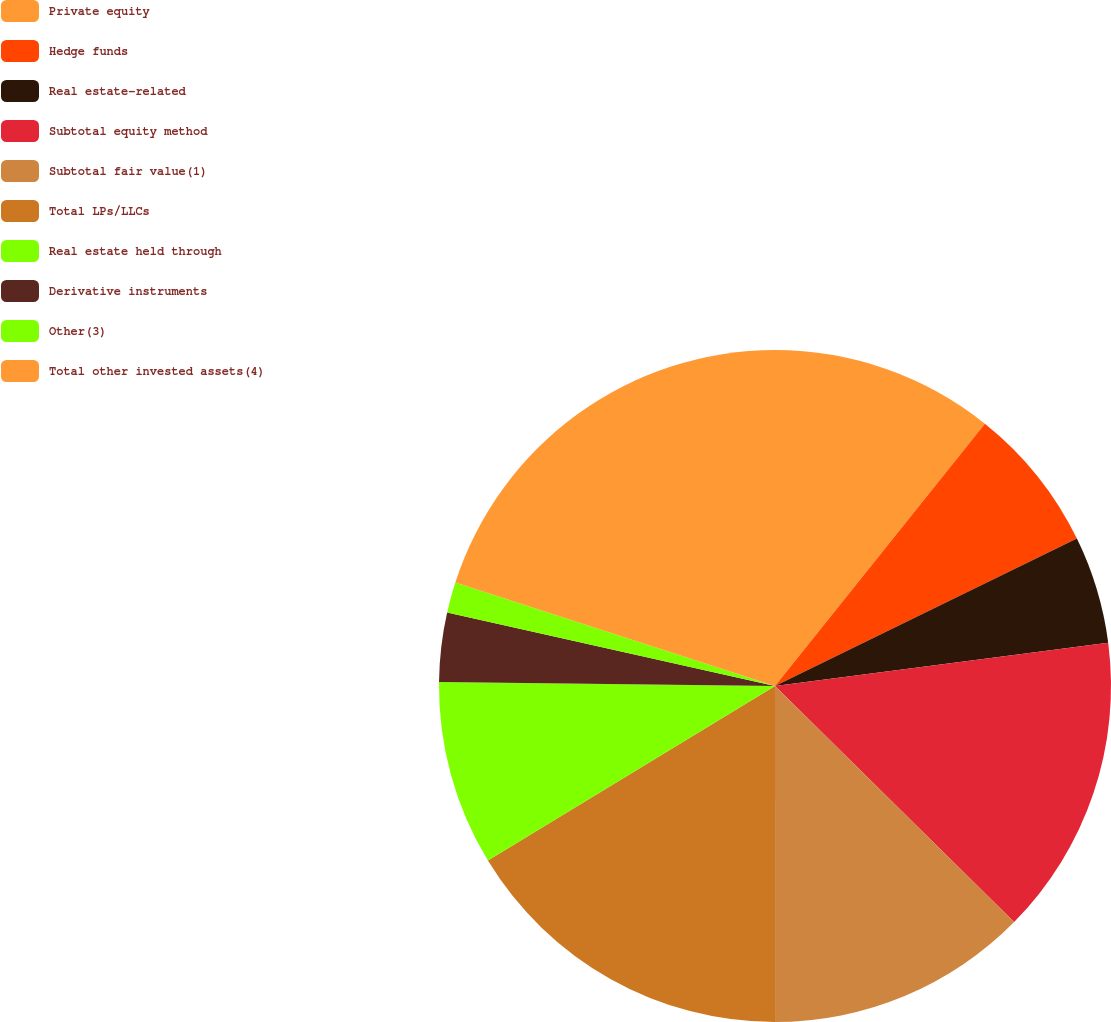<chart> <loc_0><loc_0><loc_500><loc_500><pie_chart><fcel>Private equity<fcel>Hedge funds<fcel>Real estate-related<fcel>Subtotal equity method<fcel>Subtotal fair value(1)<fcel>Total LPs/LLCs<fcel>Real estate held through<fcel>Derivative instruments<fcel>Other(3)<fcel>Total other invested assets(4)<nl><fcel>10.74%<fcel>7.03%<fcel>5.18%<fcel>14.45%<fcel>12.6%<fcel>16.31%<fcel>8.89%<fcel>3.32%<fcel>1.47%<fcel>20.02%<nl></chart> 